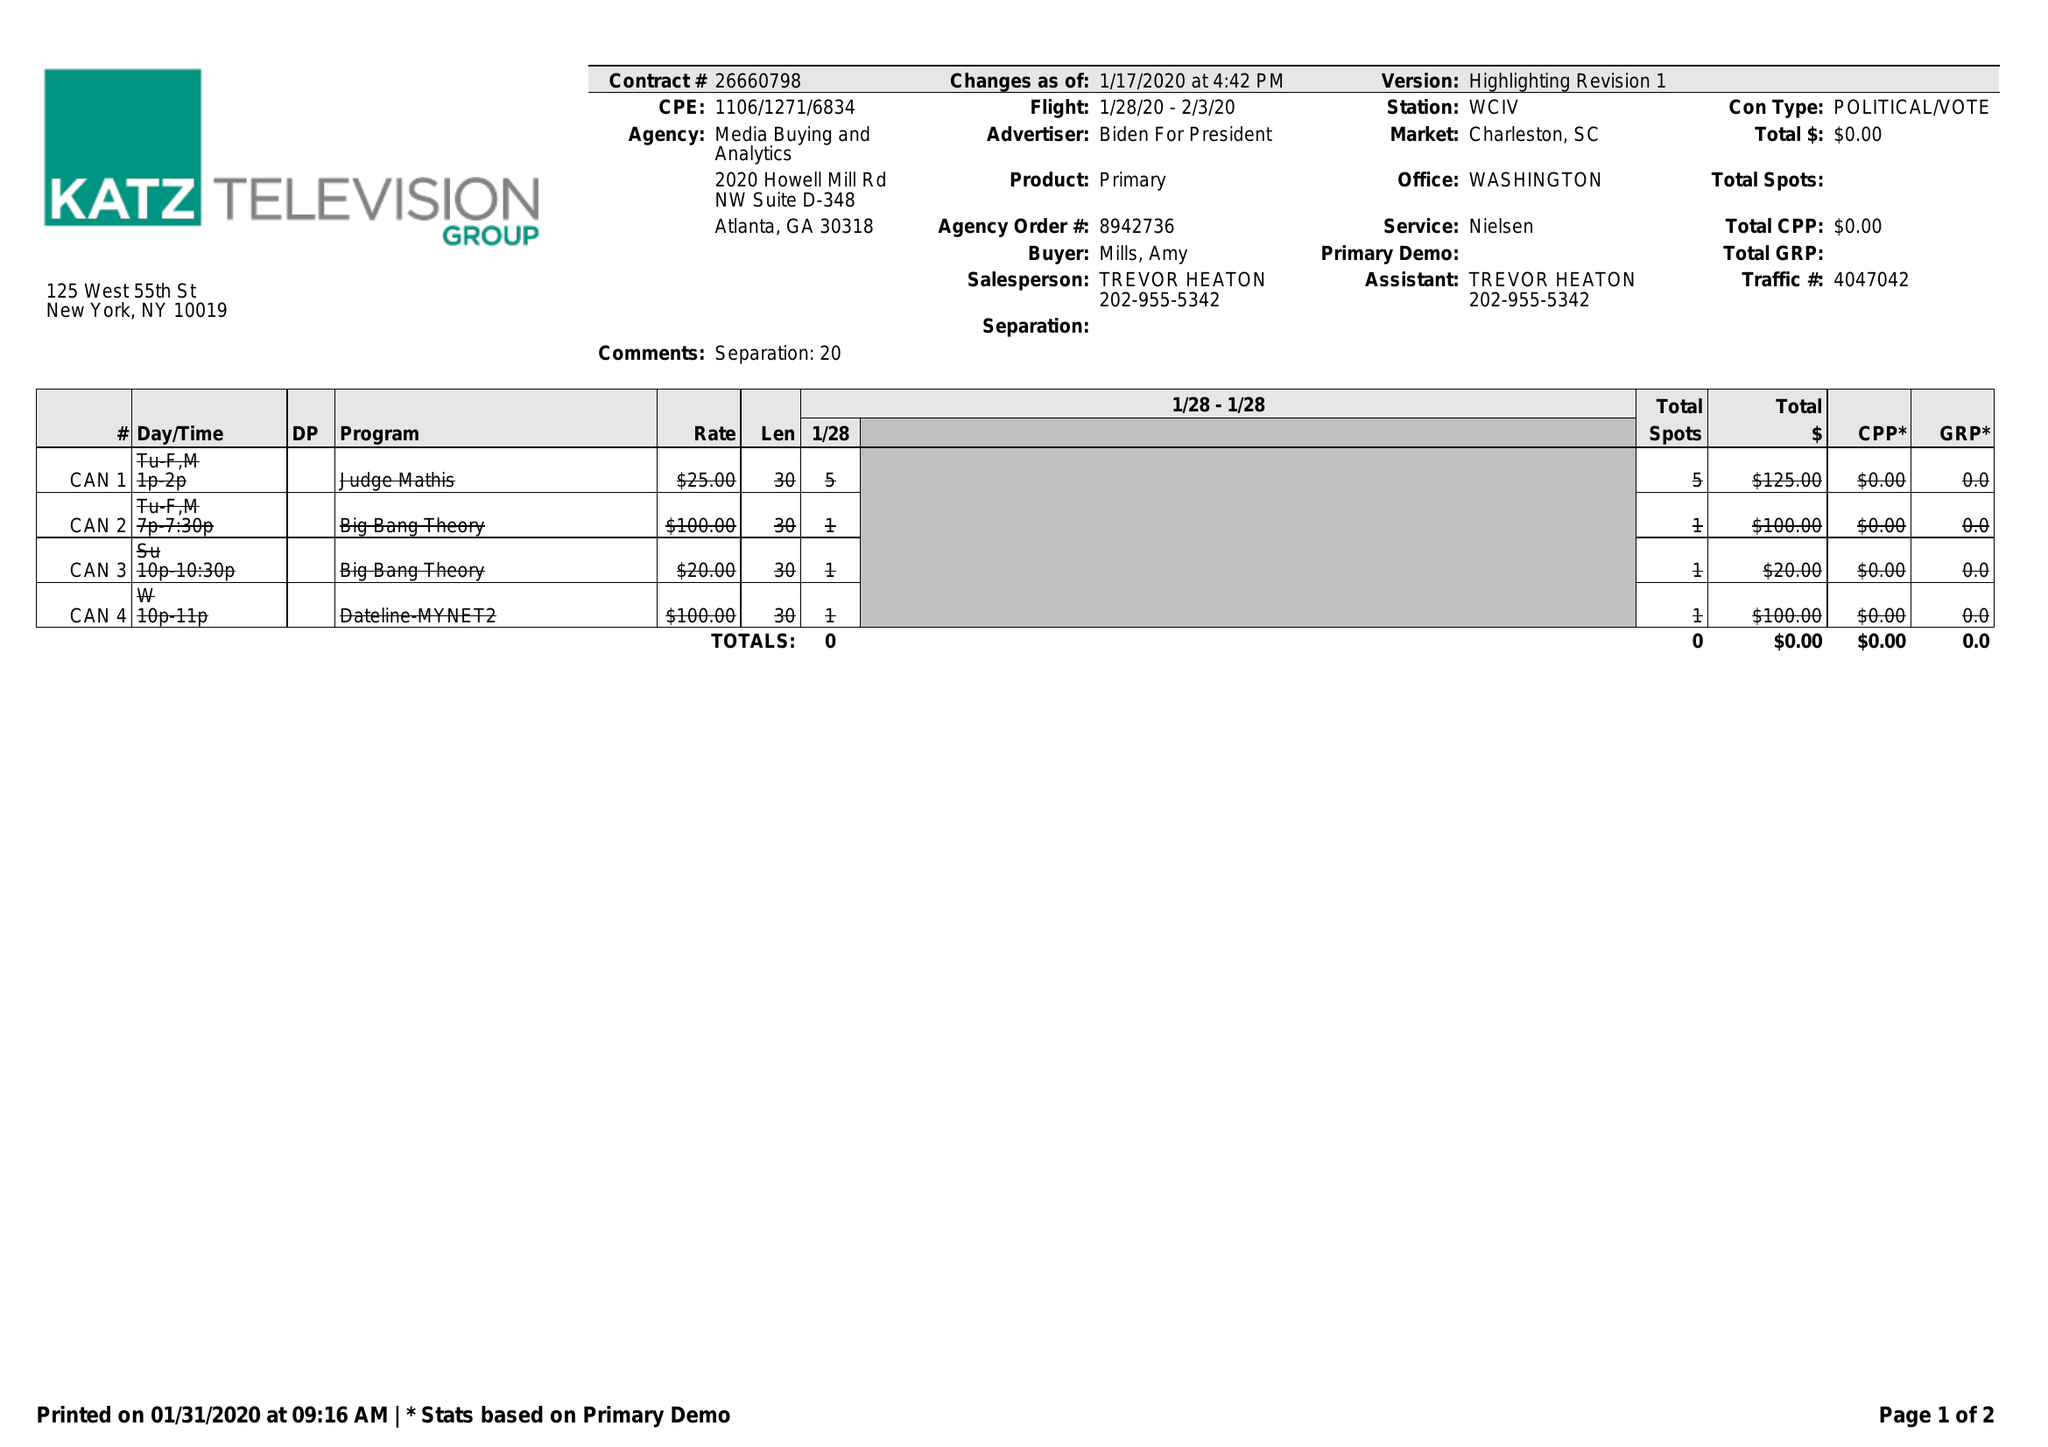What is the value for the gross_amount?
Answer the question using a single word or phrase. 0.00 